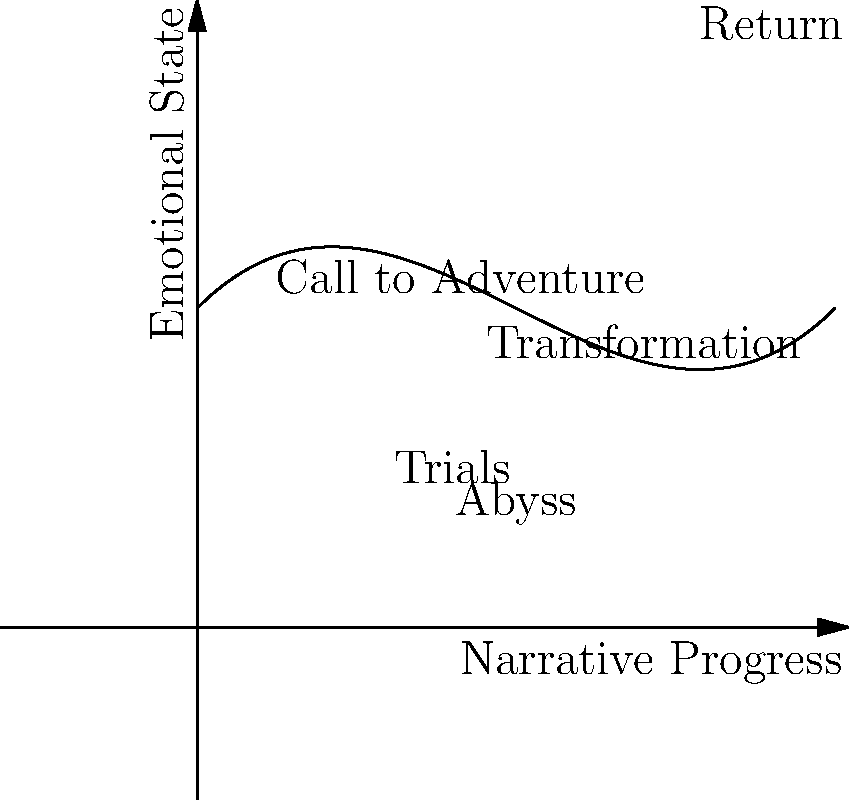Analyze the character arc depicted in the graph, which represents the emotional development of a hero in a classical narrative structure. Identify the lowest point of the hero's journey and explain its significance in terms of Joseph Campbell's monomyth theory. To analyze this character arc and identify the lowest point, we'll follow these steps:

1. Observe the overall shape of the graph:
   The curve starts high, dips down, and then rises again, representing the hero's emotional journey.

2. Identify key points in the hero's journey:
   a. "Call to Adventure" - The starting point of the journey
   b. "Trials" - A period of challenges, shown by the descending curve
   c. "Abyss" - The lowest point on the graph
   d. "Transformation" - The turning point where the curve begins to ascend
   e. "Return" - The final high point of the journey

3. Locate the lowest point:
   The lowest point on the graph is labeled "Abyss," occurring just before the midpoint of the narrative progress.

4. Interpret the significance of the "Abyss" in Campbell's monomyth:
   a. In Campbell's theory, this point represents the "Ordeal" or "Supreme Ordeal"
   b. It's a moment of extreme crisis or challenge for the hero
   c. Often involves a symbolic death and rebirth
   d. Marks the transition from the old self to the new, transformed self

5. Understand the function of the "Abyss" in classical storytelling:
   a. Creates dramatic tension
   b. Tests the hero's resolve and character
   c. Forces the hero to confront their deepest fears or weaknesses
   d. Sets the stage for the hero's transformation and ultimate triumph

6. Recognize the "Abyss" as a pivotal moment:
   It's the turning point that leads to the hero's transformation and eventual return, completing the circular nature of the monomyth.
Answer: The "Abyss," representing the Supreme Ordeal in Campbell's monomyth, is the lowest point where the hero faces their greatest challenge, leading to transformation. 